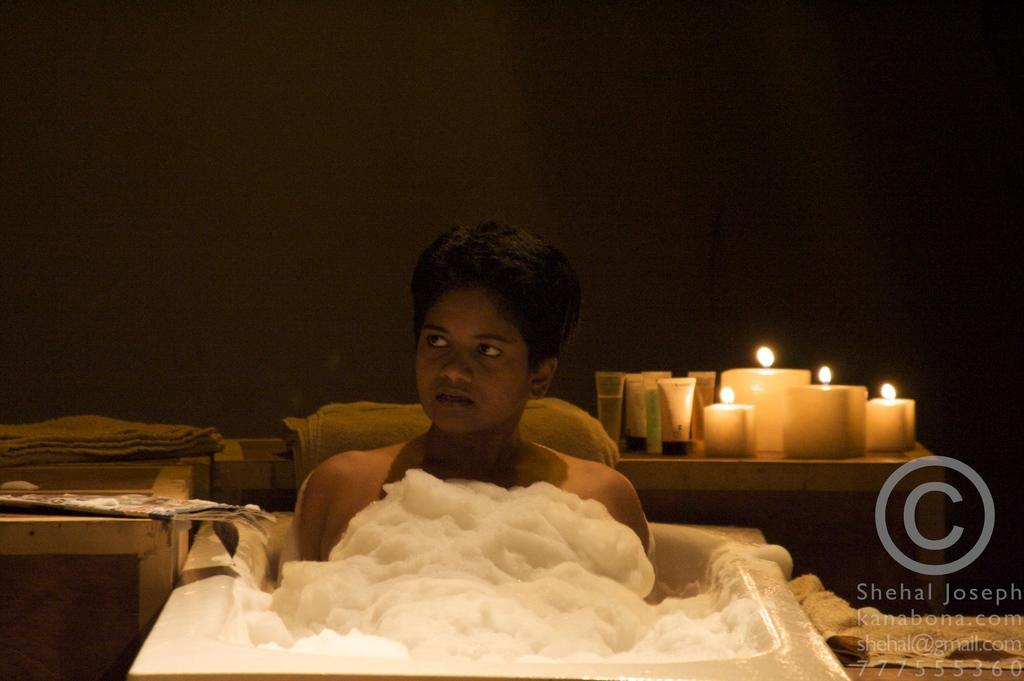What is the main subject of the image? There is a person in a bath tub in the image. What items can be seen near the bath tub? There are cream tubes and candles visible in the image. What might be used for drying off after a bath? Towels are present on the tables in the image. Is there any indication of the image's source or ownership? Yes, there is a watermark on the image. What type of marble is visible in the image? There is no marble present in the image. What trade is being conducted in the image? There is no trade being conducted in the image; it depicts a person in a bath tub with various bathing items. 